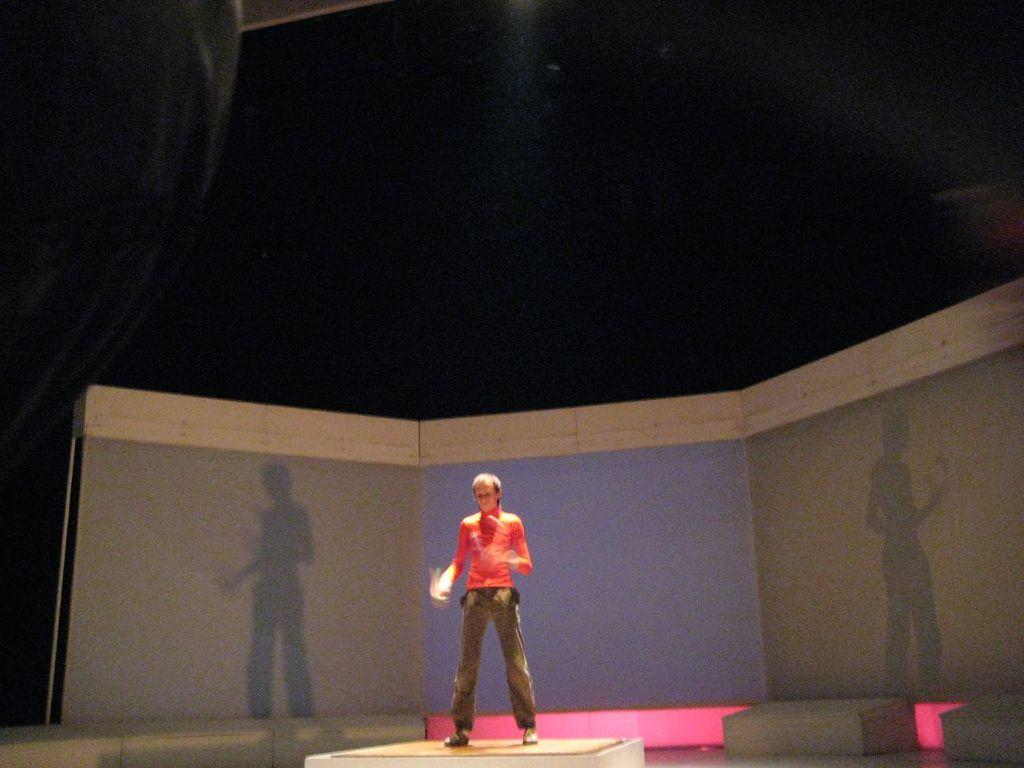What is the main feature in the center of the image? There is a stage in the center of the image. Who or what is on the stage? There is a person standing on the stage. What is the person wearing? The person is wearing an orange t-shirt. What can be seen in the background of the image? There is a wall and a roof in the background of the image. What type of finger is being used by the person on the stage to play music? There is no indication in the image that the person is playing music or using any fingers. 